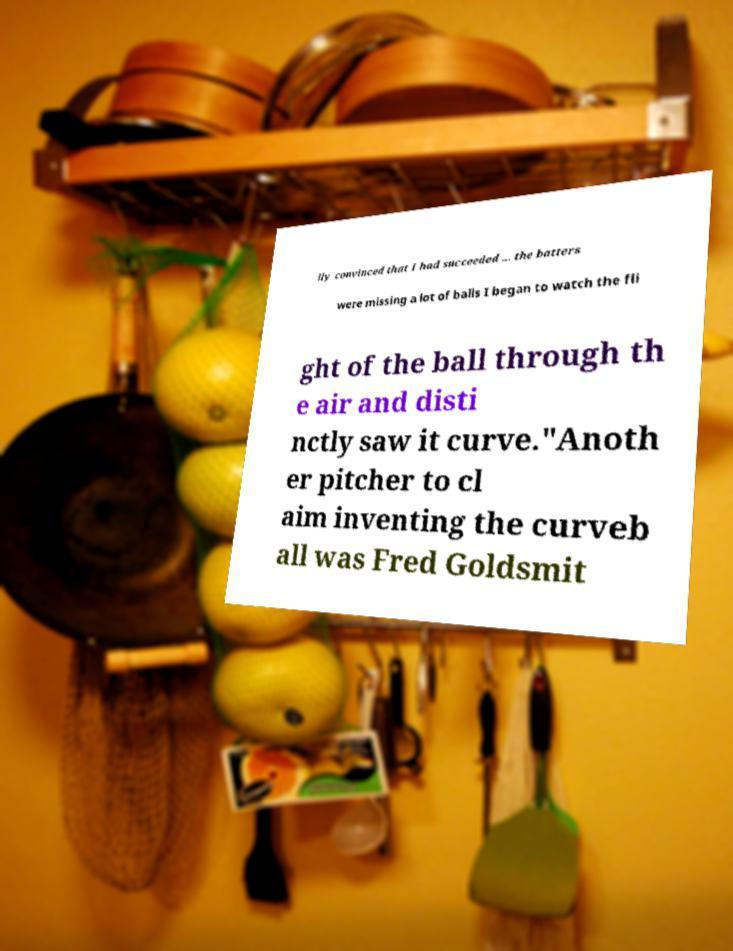There's text embedded in this image that I need extracted. Can you transcribe it verbatim? lly convinced that I had succeeded ... the batters were missing a lot of balls I began to watch the fli ght of the ball through th e air and disti nctly saw it curve."Anoth er pitcher to cl aim inventing the curveb all was Fred Goldsmit 